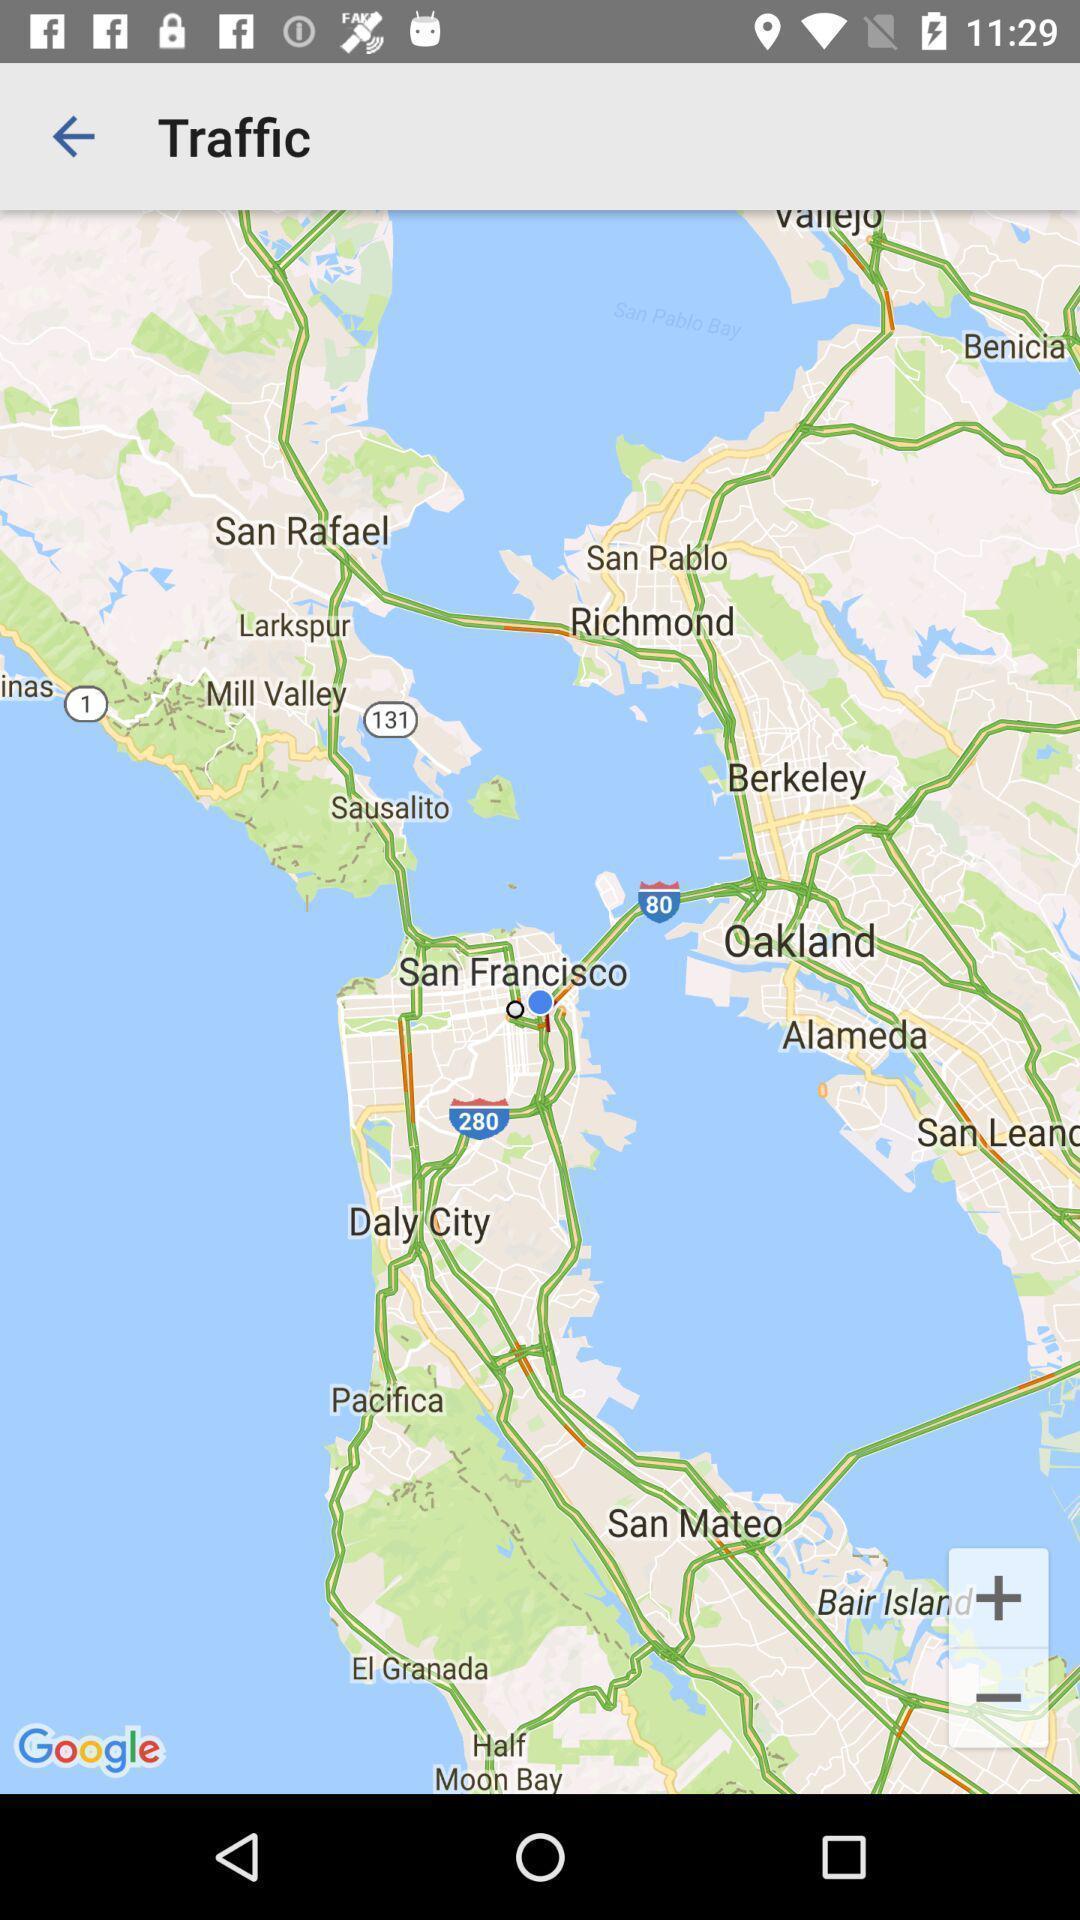Give me a narrative description of this picture. Page showing maps on a online streaming app. 